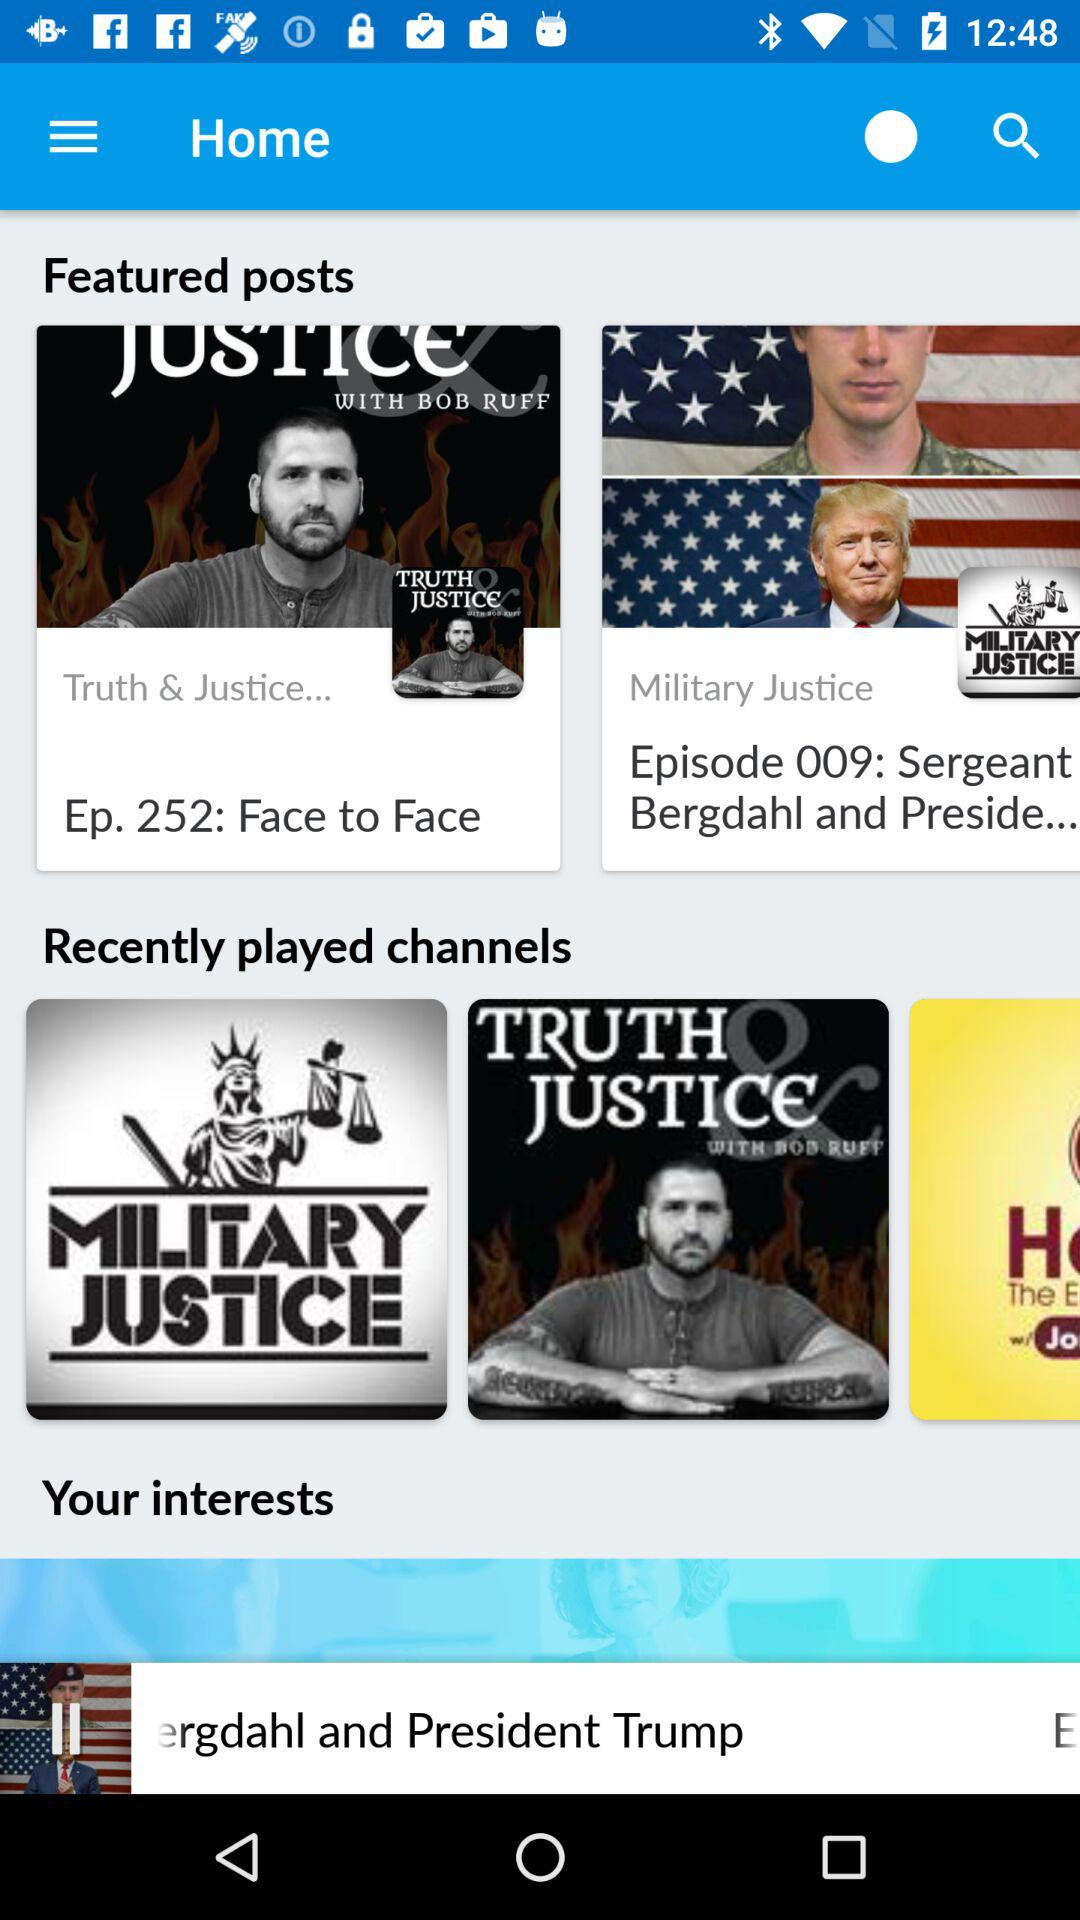How many episode does Face to Face?
When the provided information is insufficient, respond with <no answer>. <no answer> 